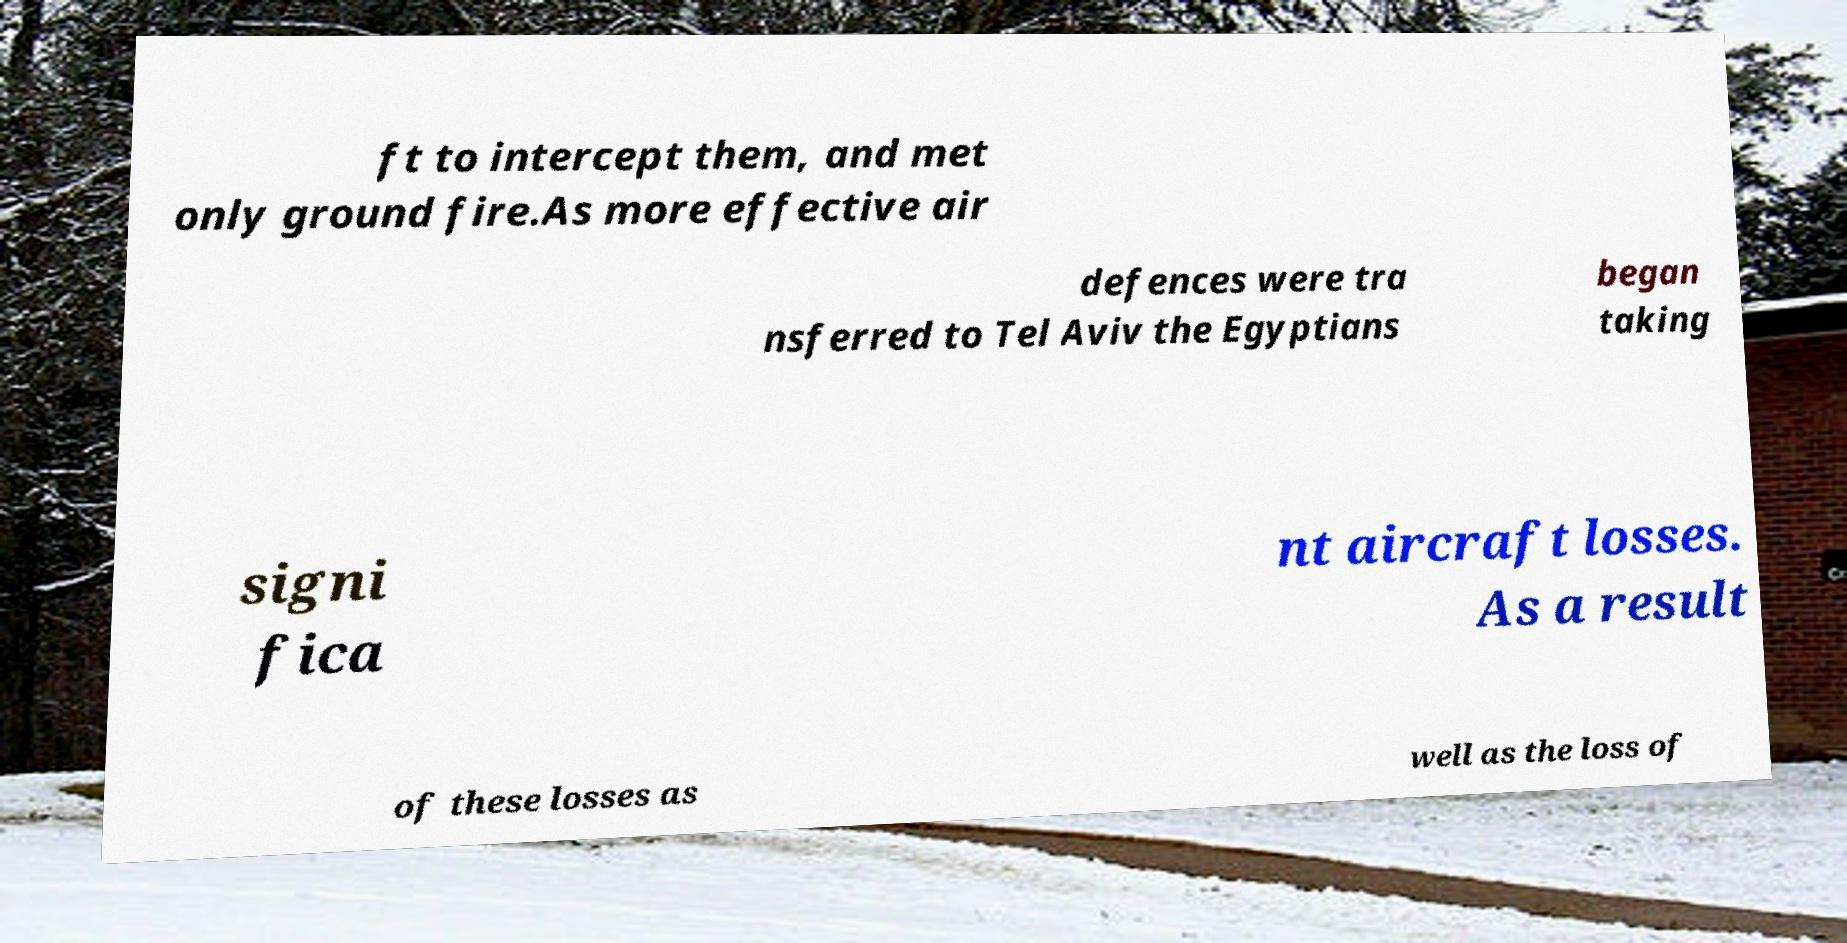Can you read and provide the text displayed in the image?This photo seems to have some interesting text. Can you extract and type it out for me? ft to intercept them, and met only ground fire.As more effective air defences were tra nsferred to Tel Aviv the Egyptians began taking signi fica nt aircraft losses. As a result of these losses as well as the loss of 